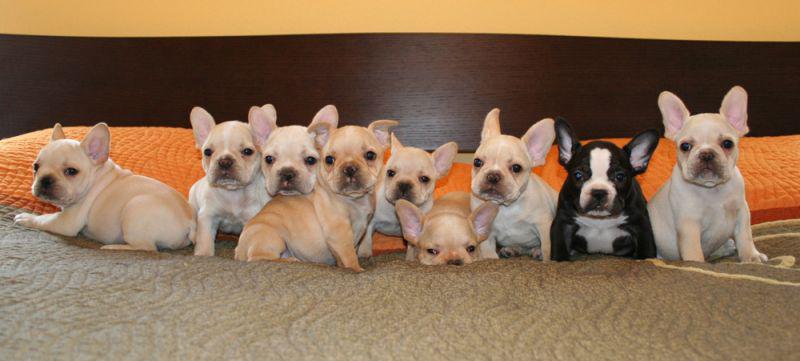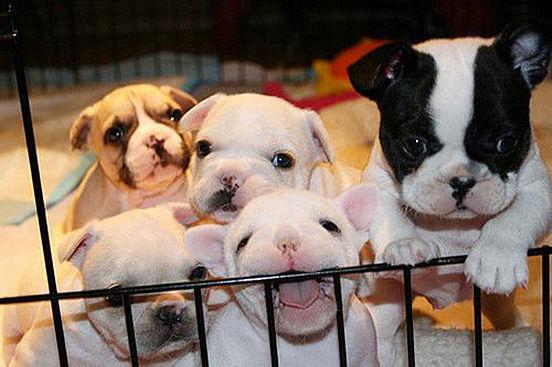The first image is the image on the left, the second image is the image on the right. Assess this claim about the two images: "One image contains more than 7 puppies.". Correct or not? Answer yes or no. Yes. The first image is the image on the left, the second image is the image on the right. Assess this claim about the two images: "There are no more than four dogs in the right image.". Correct or not? Answer yes or no. No. 